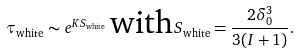<formula> <loc_0><loc_0><loc_500><loc_500>\tau _ { \text {white} } \sim e ^ { K S _ { \text {white} } } \, \text {with} \, S _ { \text {white} } = \frac { 2 \delta _ { 0 } ^ { 3 } } { 3 ( I + 1 ) } .</formula> 